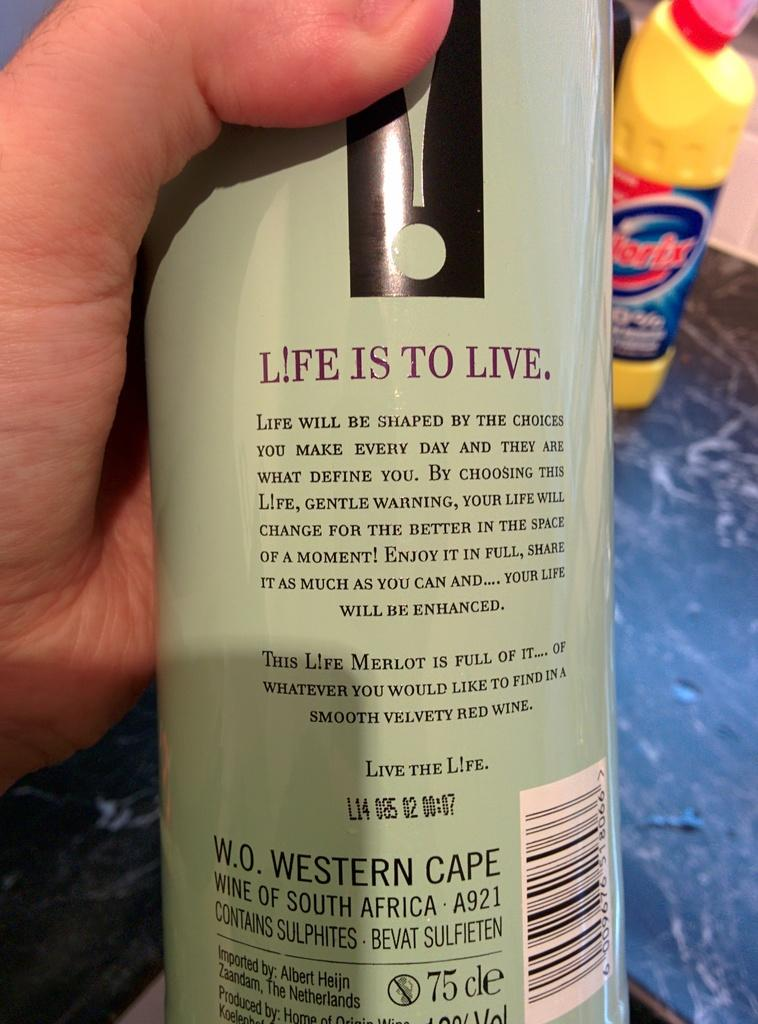<image>
Offer a succinct explanation of the picture presented. A bottle of South African wine has a message reminding people that life is to live on its label. 